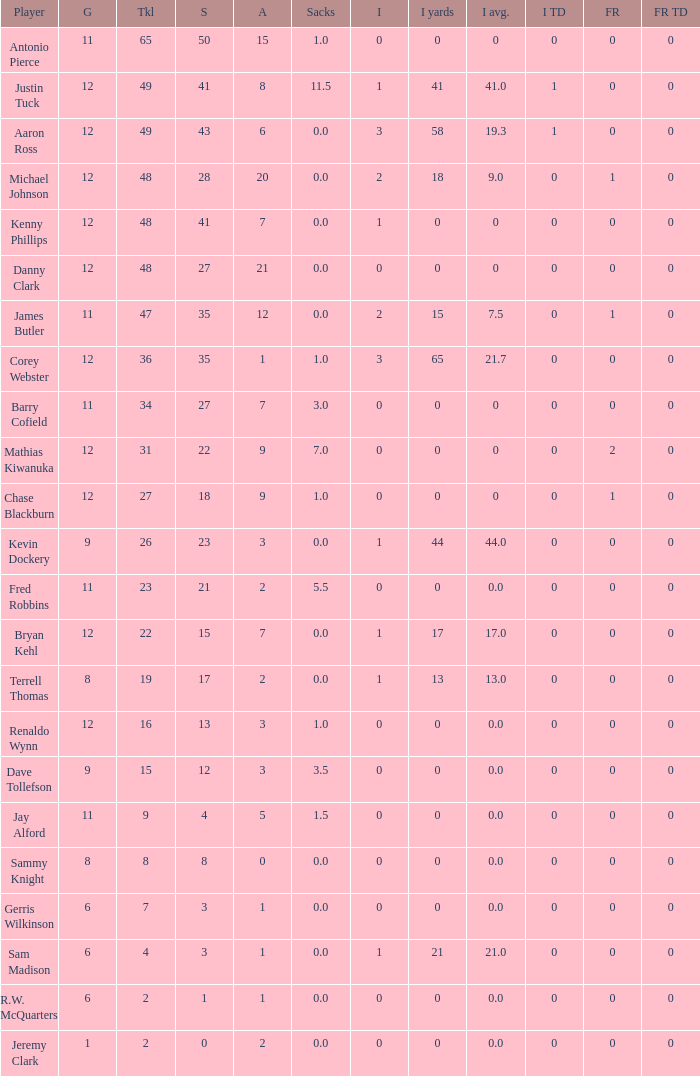Name the most tackles for 3.5 sacks 15.0. 